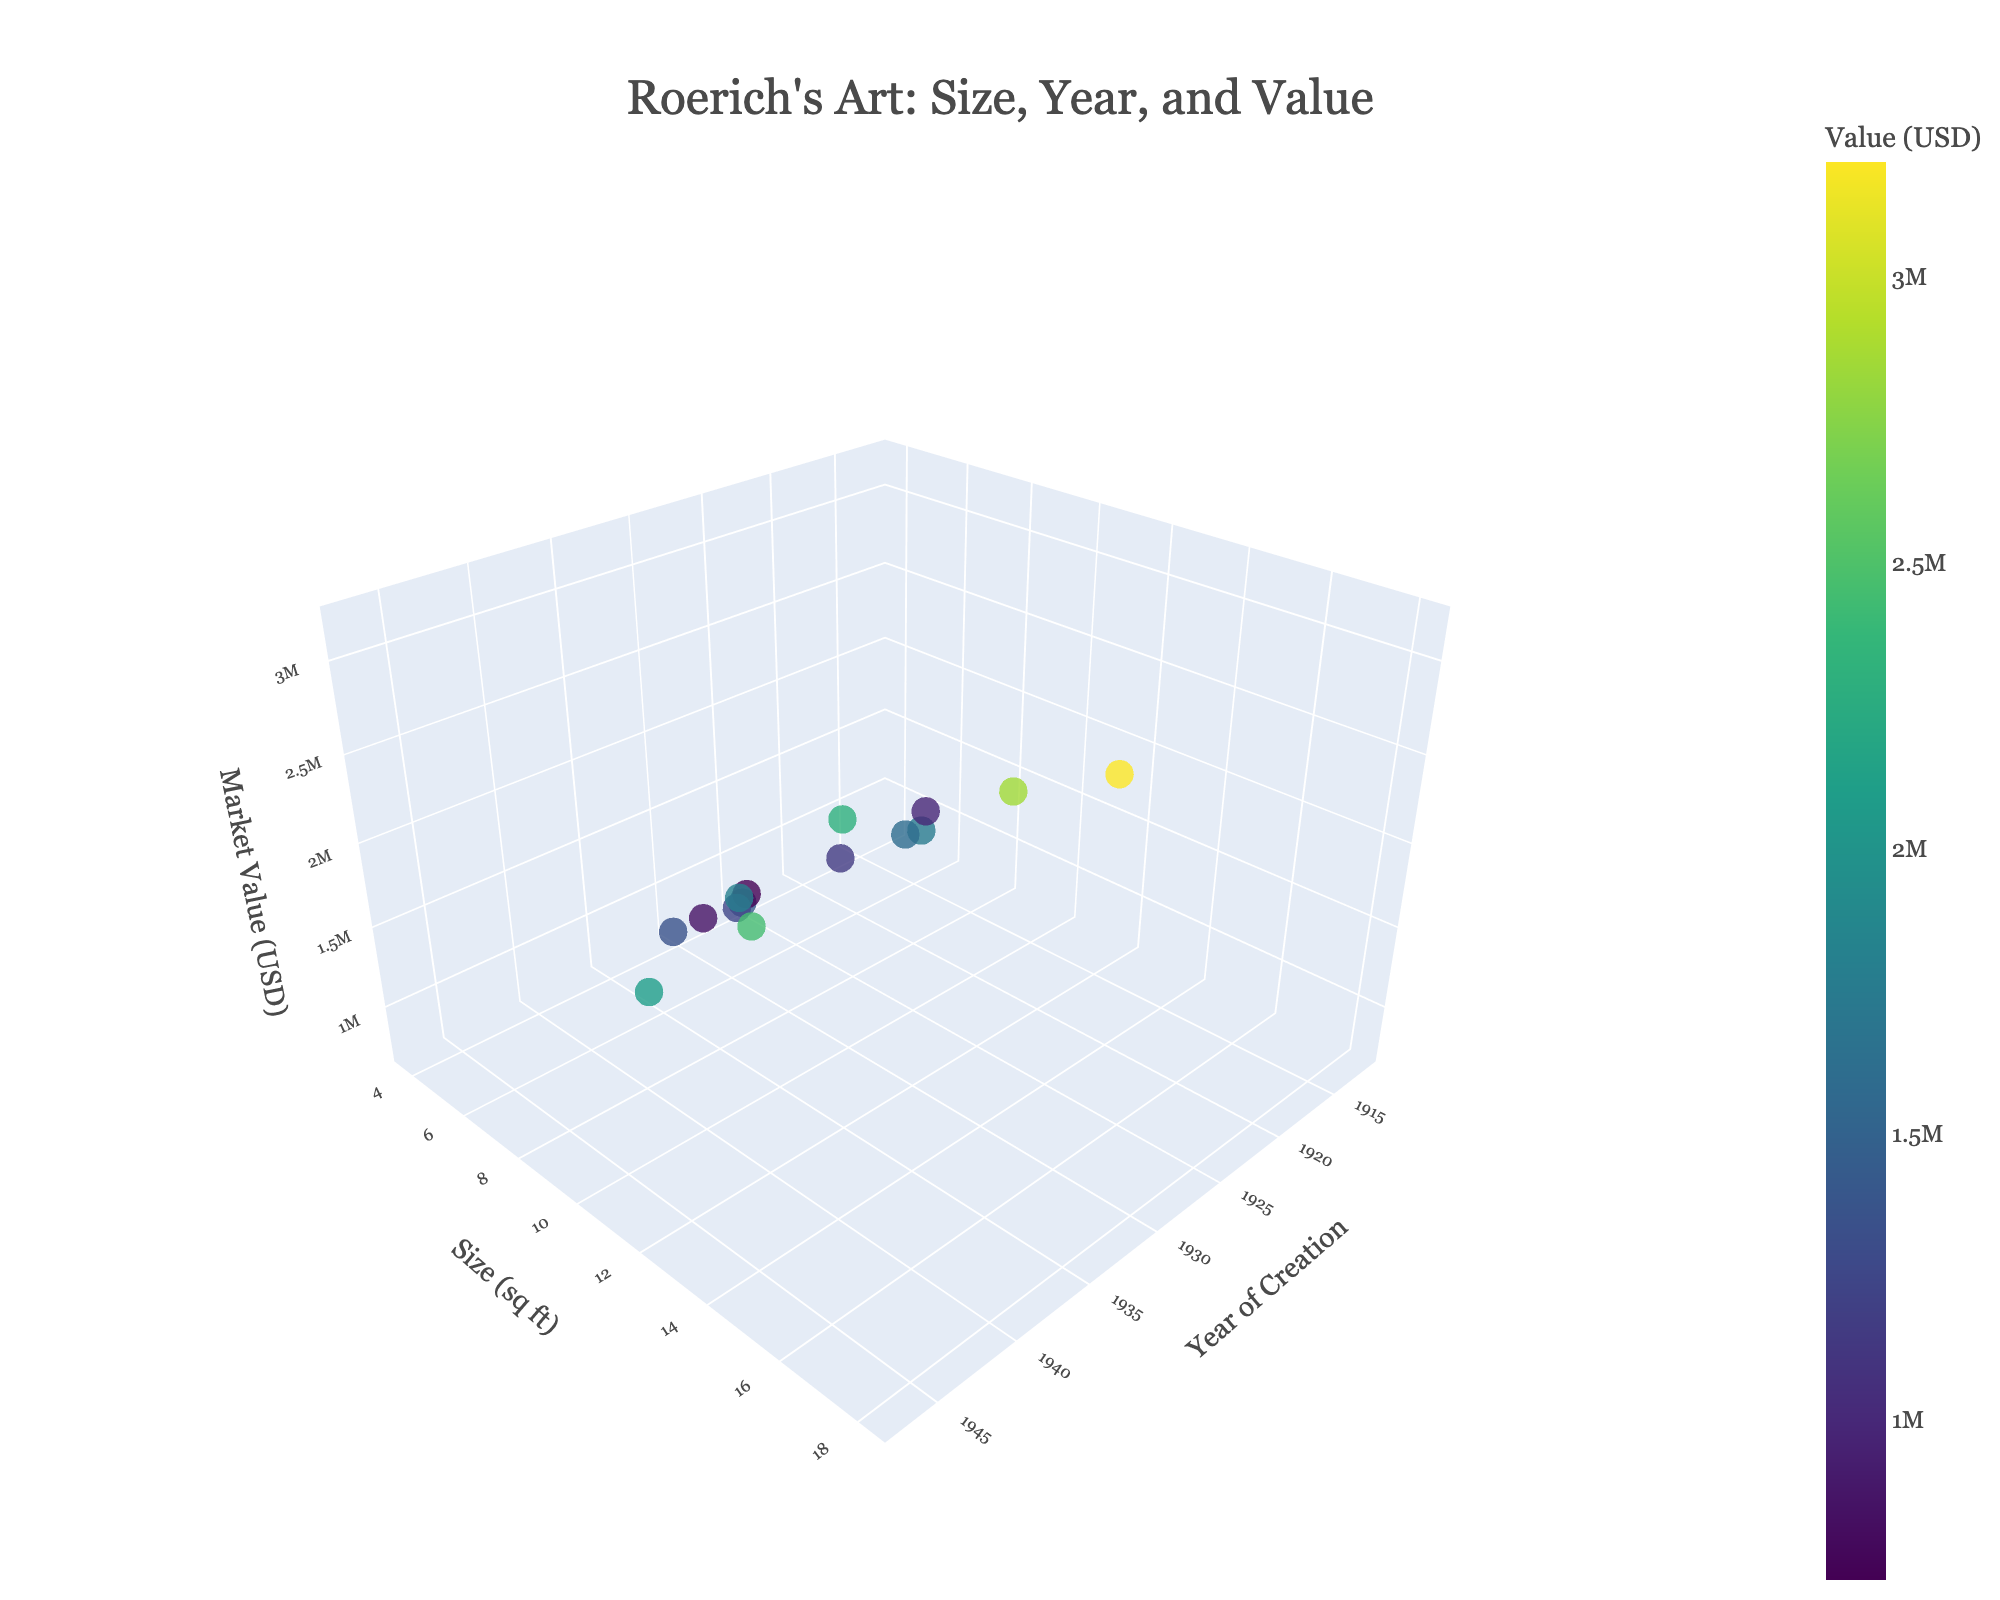Does the value of Roerich's paintings increase over the years? Look at the z-axis (Market Value) and the x-axis (Year of Creation). Observe if there's a general upward trend in market value as the years progress.
Answer: No clear trend Are larger paintings generally more valuable? Analyze the relationship between the y-axis (Size in sq ft) and the z-axis (Market Value). See if larger sizes correspond to higher market values.
Answer: Yes, generally Which painting has the highest market value? Identify the data point with the highest value on the z-axis. Check the corresponding label for this point.
Answer: The Great Spirit of the Himalayas What is the size and year of the painting "Saint Sergius of Radonezh"? Find the data point labeled "Saint Sergius of Radonezh" and read its corresponding x-axis (Year) and y-axis (Size) values.
Answer: Size: 6.3 sq ft, Year: 1922 How many paintings were created before 1930? Count the data points that fall left of the 1930 mark on the x-axis.
Answer: 7 paintings Is there a cluster of paintings created in any specific decade? Observe if there is a higher density of data points along any particular range on the x-axis.
Answer: 1920s and 1930s Which painting is the most recent, and what is its market value? Locate the rightmost data point on the x-axis (Year). Check its corresponding value on the z-axis.
Answer: Command of Rigden Djapo, $2,100,000 Compare the sizes of the paintings "Mother of the World" and "Drops of Life". Which one is larger? Find the data points labeled "Mother of the World" and "Drops of Life". Compare their y-axis (Size) values.
Answer: Mother of the World What's the average market value of paintings created in the 1920s? Identify the paintings created between 1920-1929. Add their market values and divide by the number of paintings.
Answer: $1,342,167 Does the painting with the highest size also have the highest market value? Identify the painting with the highest y-axis (Size) value and compare its z-axis (Market Value) to that of the painting with the highest market value.
Answer: No 